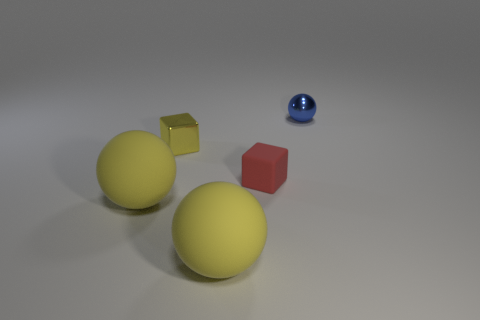What moods or themes could this image evoke in a viewer? The simplicity and clarity of the image, combined with the pastel colors and soft lighting, might evoke feelings of calmness and order. There's an almost minimalist aesthetic at play that can lead to various interpretations, such as solitude, reflection, or the beauty found in simple forms and structures. 